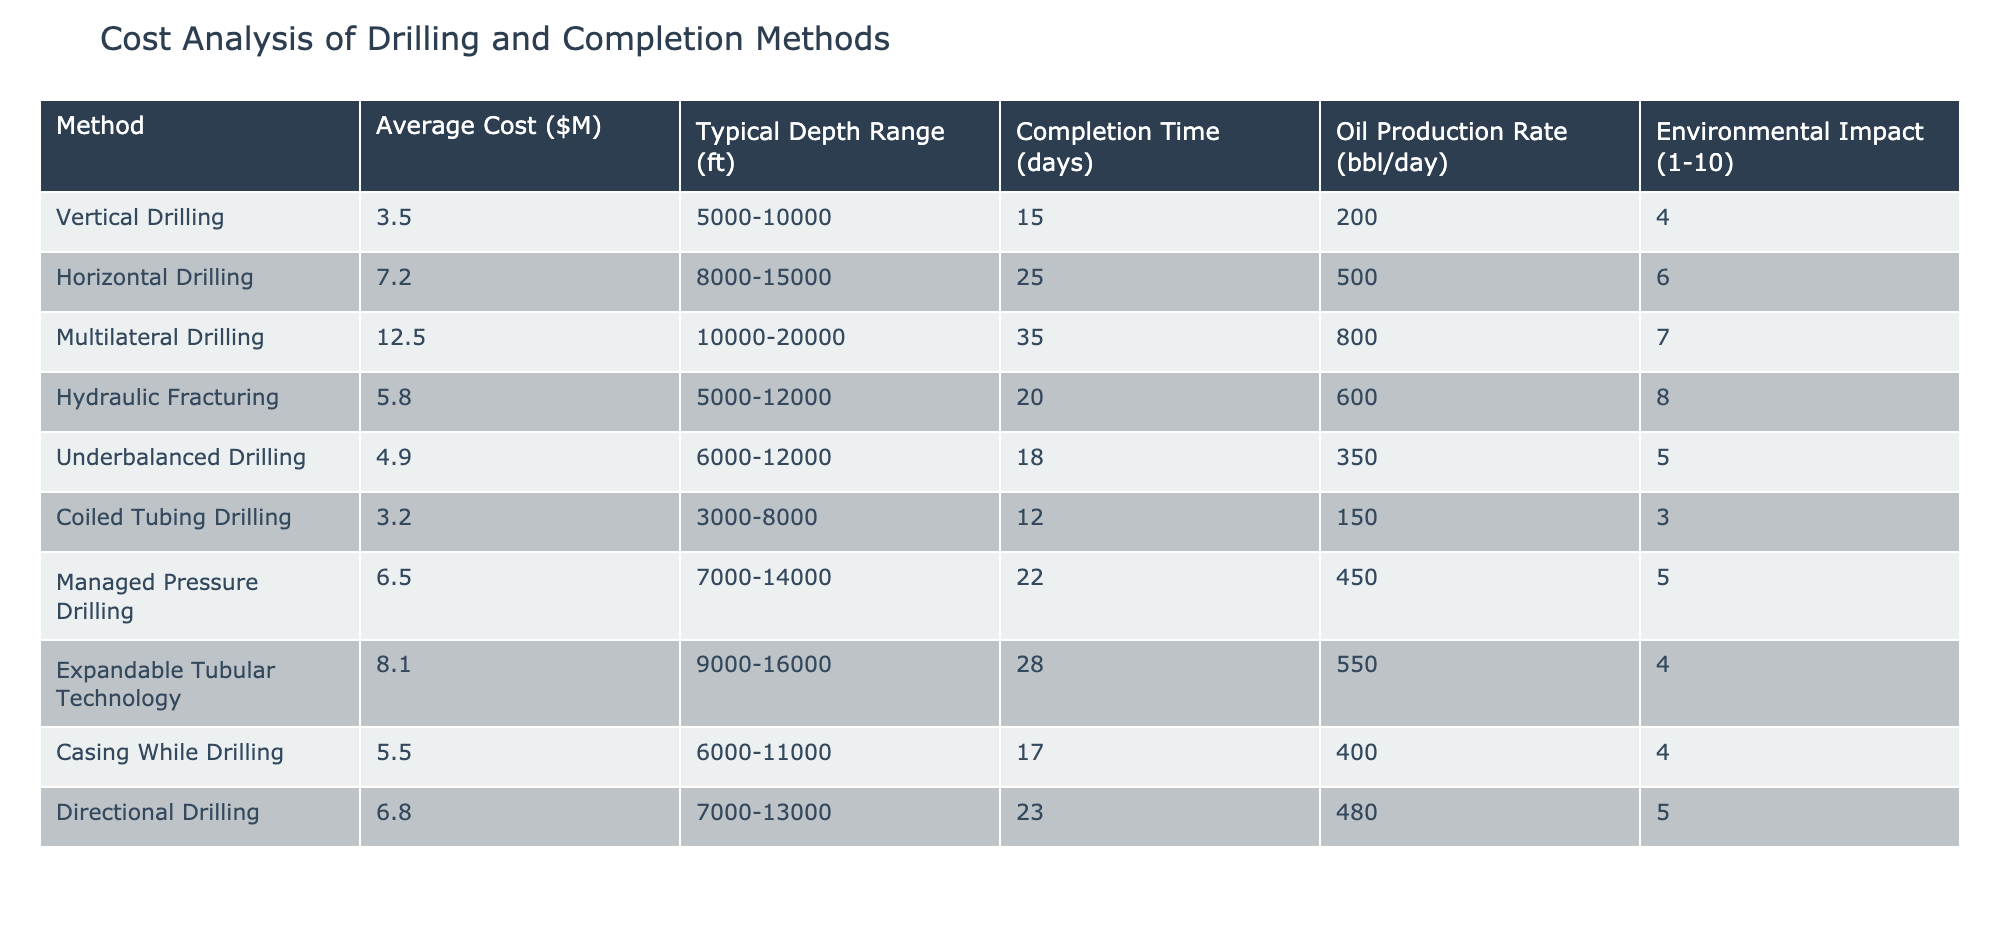What is the average cost of vertical drilling? The average cost listed for vertical drilling in the table is 3.5 million dollars.
Answer: 3.5 million dollars Which drilling method has the longest completion time? By comparing the completion times in the table, multilateral drilling has the longest time at 35 days.
Answer: Multilateral drilling What is the oil production rate of horizontal drilling? The table indicates that the oil production rate for horizontal drilling is 500 barrels per day.
Answer: 500 barrels per day Is the environmental impact of hydraulic fracturing higher than that of coiled tubing drilling? Hydraulic fracturing has an environmental impact rating of 8, whereas coiled tubing drilling has a rating of 3. Therefore, yes, hydraulic fracturing has a higher impact.
Answer: Yes What is the average oil production rate of all drilling methods listed? To find the average, sum the oil production rates: 200 + 500 + 800 + 600 + 350 + 150 + 450 + 550 + 400 + 480 = 4130, then divide by 10 methods: 4130 / 10 = 413.
Answer: 413 barrels per day How does the average cost of underbalanced drilling compare to that of hydraulic fracturing? Underbalanced drilling costs 4.9 million dollars and hydraulic fracturing costs 5.8 million dollars. Hydraulic fracturing is more expensive by 0.9 million dollars.
Answer: Hydraulic fracturing is more expensive Which method offers the least environmental impact? By examining the environmental impact ratings in the table, coiled tubing drilling scores the lowest at 3.
Answer: Coiled tubing drilling What is the difference in average cost between multilateral drilling and coiled tubing drilling? The average cost of multilateral drilling is 12.5 million dollars and for coiled tubing drilling it's 3.2 million dollars. The difference is 12.5 - 3.2 = 9.3 million dollars.
Answer: 9.3 million dollars Are there any methods with a cost between 5 and 7 million dollars? Checking the costs in the table, underbalanced drilling (4.9 million) and hydraulic fracturing (5.8 million) and directional drilling (6.8 million) are below or near 7 million, so yes, there are methods within that range.
Answer: Yes 